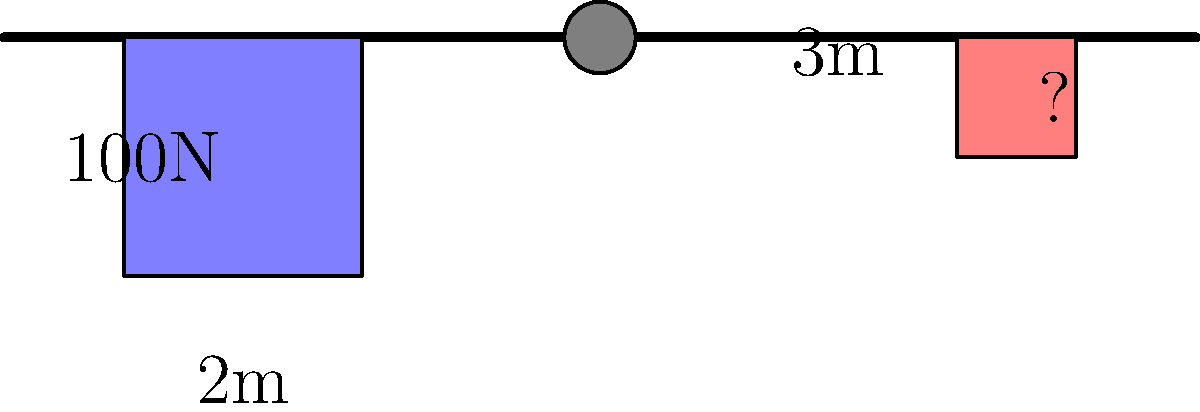In a lever system used to lift heavy objects, a 100N weight is placed 2m from the fulcrum on one side. What weight should be placed 3m from the fulcrum on the other side to achieve balance? How does this demonstrate mechanical advantage? To solve this problem, we'll use the principle of moments and the concept of mechanical advantage in a lever system:

1) The principle of moments states that for a lever to be in equilibrium, the sum of clockwise moments must equal the sum of counterclockwise moments about the fulcrum.

2) Moment = Force × Distance from fulcrum

3) Let the unknown weight be $x$ N.

4) Writing the equation:
   $100 \text{ N} \times 2 \text{ m} = x \text{ N} \times 3 \text{ m}$

5) Solving for $x$:
   $200 \text{ Nm} = 3x \text{ Nm}$
   $x = \frac{200}{3} \approx 66.67 \text{ N}$

6) This demonstrates mechanical advantage because a smaller force (66.67N) at a greater distance from the fulcrum can balance a larger force (100N) at a shorter distance.

7) The mechanical advantage (MA) can be calculated as:
   $MA = \frac{\text{Distance of load from fulcrum}}{\text{Distance of effort from fulcrum}} = \frac{3}{2} = 1.5$

This means that the effort force is 1.5 times more effective due to its position on the lever.
Answer: 66.67N; It allows a smaller force to balance a larger one by leveraging distance. 